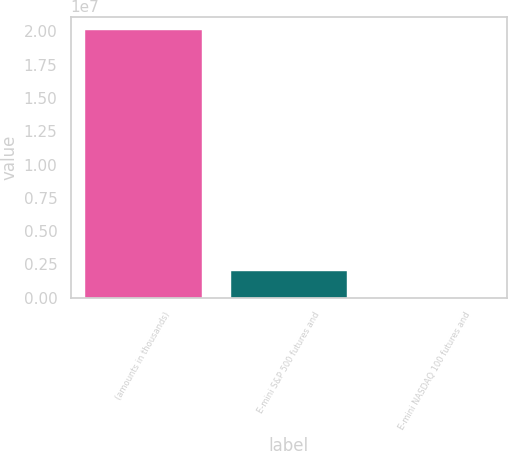Convert chart to OTSL. <chart><loc_0><loc_0><loc_500><loc_500><bar_chart><fcel>(amounts in thousands)<fcel>E-mini S&P 500 futures and<fcel>E-mini NASDAQ 100 futures and<nl><fcel>2.0112e+07<fcel>2.01121e+06<fcel>5<nl></chart> 